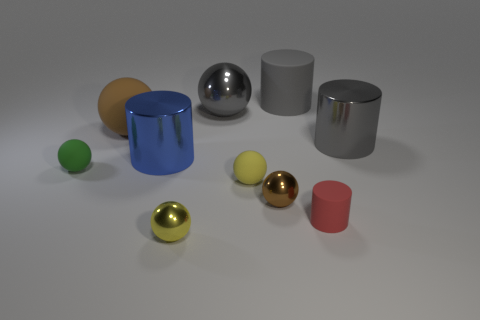Subtract all brown balls. How many balls are left? 4 Subtract all yellow spheres. How many gray cylinders are left? 2 Subtract 2 cylinders. How many cylinders are left? 2 Subtract all green balls. How many balls are left? 5 Subtract all balls. How many objects are left? 4 Subtract 0 gray blocks. How many objects are left? 10 Subtract all gray spheres. Subtract all gray cubes. How many spheres are left? 5 Subtract all small red metallic balls. Subtract all small cylinders. How many objects are left? 9 Add 2 tiny brown metallic spheres. How many tiny brown metallic spheres are left? 3 Add 1 gray metal objects. How many gray metal objects exist? 3 